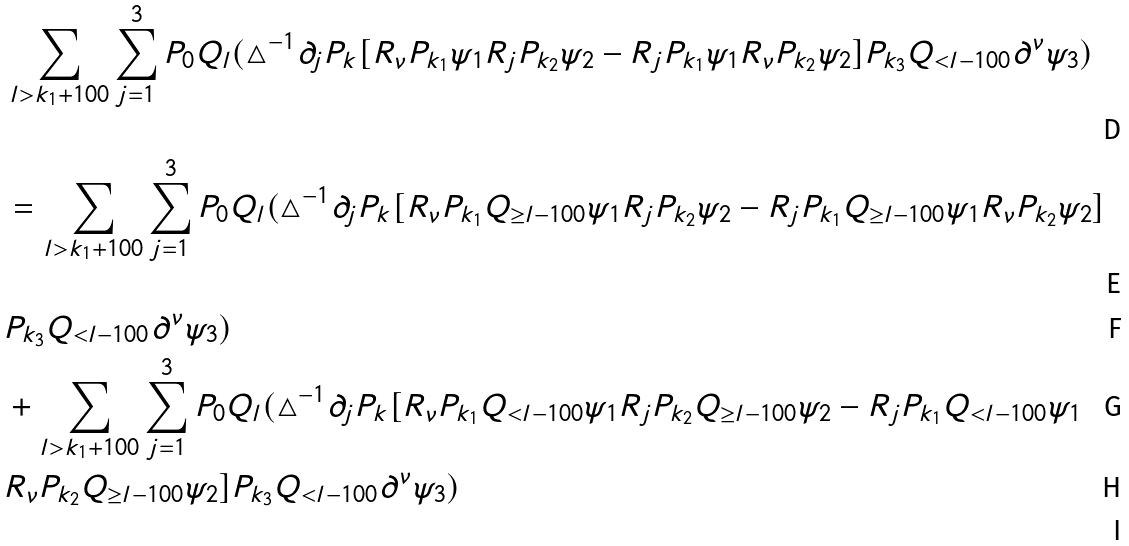Convert formula to latex. <formula><loc_0><loc_0><loc_500><loc_500>& \sum _ { l > k _ { 1 } + 1 0 0 } \sum _ { j = 1 } ^ { 3 } P _ { 0 } Q _ { l } ( \triangle ^ { - 1 } \partial _ { j } P _ { k } [ R _ { \nu } P _ { k _ { 1 } } \psi _ { 1 } R _ { j } P _ { k _ { 2 } } \psi _ { 2 } - R _ { j } P _ { k _ { 1 } } \psi _ { 1 } R _ { \nu } P _ { k _ { 2 } } \psi _ { 2 } ] P _ { k _ { 3 } } Q _ { < l - 1 0 0 } \partial ^ { \nu } \psi _ { 3 } ) \\ & = \sum _ { l > k _ { 1 } + 1 0 0 } \sum _ { j = 1 } ^ { 3 } P _ { 0 } Q _ { l } ( \triangle ^ { - 1 } \partial _ { j } P _ { k } [ R _ { \nu } P _ { k _ { 1 } } Q _ { \geq l - 1 0 0 } \psi _ { 1 } R _ { j } P _ { k _ { 2 } } \psi _ { 2 } - R _ { j } P _ { k _ { 1 } } Q _ { \geq l - 1 0 0 } \psi _ { 1 } R _ { \nu } P _ { k _ { 2 } } \psi _ { 2 } ] \\ & P _ { k _ { 3 } } Q _ { < l - 1 0 0 } \partial ^ { \nu } \psi _ { 3 } ) \\ & + \sum _ { l > k _ { 1 } + 1 0 0 } \sum _ { j = 1 } ^ { 3 } P _ { 0 } Q _ { l } ( \triangle ^ { - 1 } \partial _ { j } P _ { k } [ R _ { \nu } P _ { k _ { 1 } } Q _ { < l - 1 0 0 } \psi _ { 1 } R _ { j } P _ { k _ { 2 } } Q _ { \geq l - 1 0 0 } \psi _ { 2 } - R _ { j } P _ { k _ { 1 } } Q _ { < l - 1 0 0 } \psi _ { 1 } \\ & R _ { \nu } P _ { k _ { 2 } } Q _ { \geq l - 1 0 0 } \psi _ { 2 } ] P _ { k _ { 3 } } Q _ { < l - 1 0 0 } \partial ^ { \nu } \psi _ { 3 } ) \\</formula> 